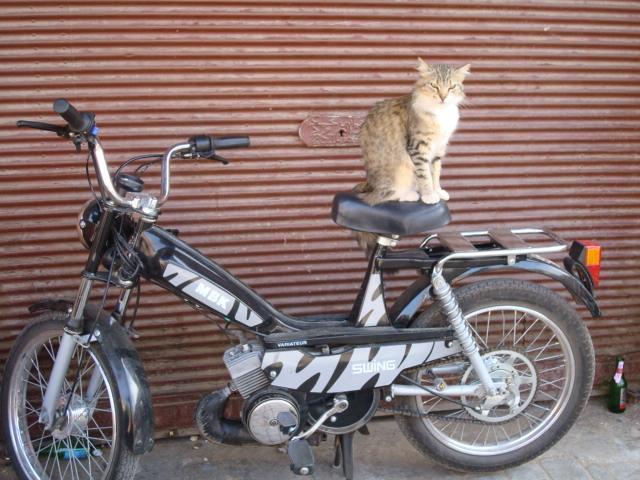How many tires are there?
Give a very brief answer. 2. 